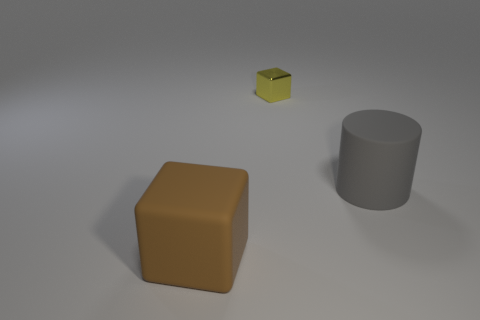Add 2 purple metallic blocks. How many objects exist? 5 Subtract all cylinders. How many objects are left? 2 Add 3 rubber cylinders. How many rubber cylinders exist? 4 Subtract 1 gray cylinders. How many objects are left? 2 Subtract all big brown rubber objects. Subtract all big gray cubes. How many objects are left? 2 Add 2 big rubber objects. How many big rubber objects are left? 4 